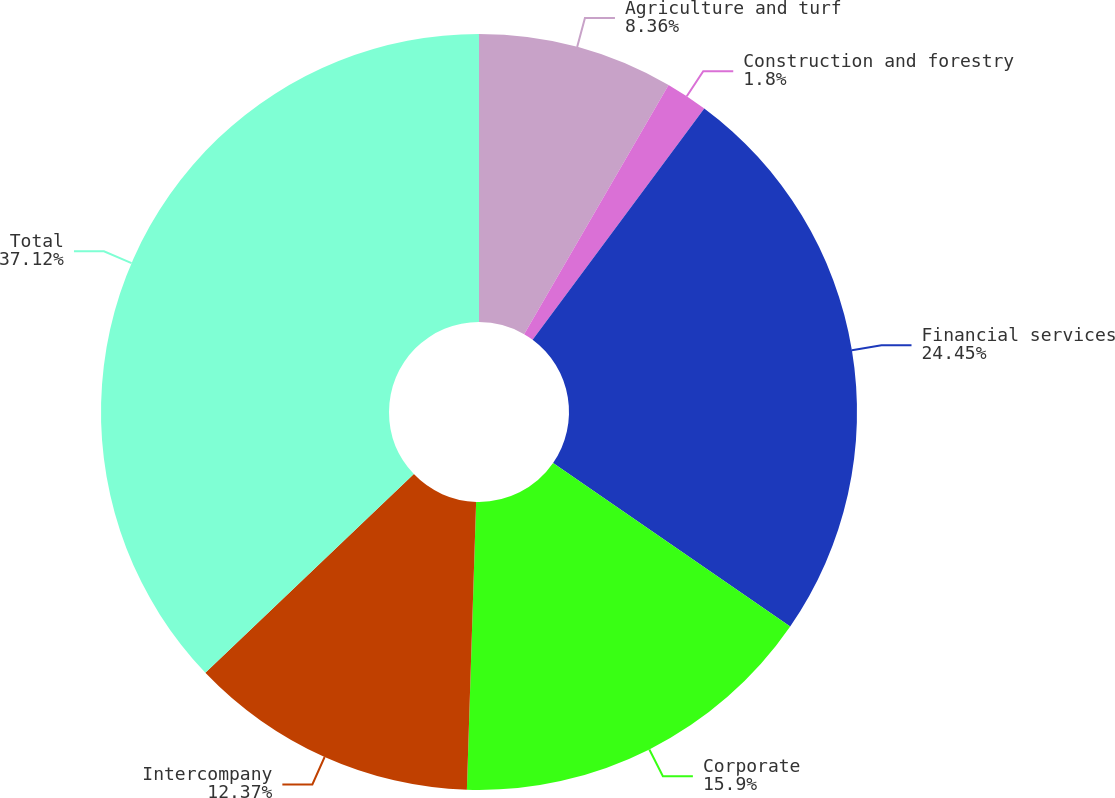Convert chart to OTSL. <chart><loc_0><loc_0><loc_500><loc_500><pie_chart><fcel>Agriculture and turf<fcel>Construction and forestry<fcel>Financial services<fcel>Corporate<fcel>Intercompany<fcel>Total<nl><fcel>8.36%<fcel>1.8%<fcel>24.44%<fcel>15.9%<fcel>12.37%<fcel>37.11%<nl></chart> 